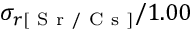Convert formula to latex. <formula><loc_0><loc_0><loc_500><loc_500>\sigma _ { r [ S r / C s ] } / 1 . 0 0</formula> 